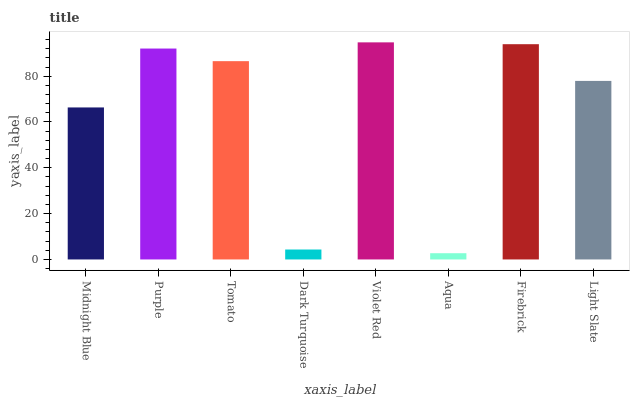Is Aqua the minimum?
Answer yes or no. Yes. Is Violet Red the maximum?
Answer yes or no. Yes. Is Purple the minimum?
Answer yes or no. No. Is Purple the maximum?
Answer yes or no. No. Is Purple greater than Midnight Blue?
Answer yes or no. Yes. Is Midnight Blue less than Purple?
Answer yes or no. Yes. Is Midnight Blue greater than Purple?
Answer yes or no. No. Is Purple less than Midnight Blue?
Answer yes or no. No. Is Tomato the high median?
Answer yes or no. Yes. Is Light Slate the low median?
Answer yes or no. Yes. Is Aqua the high median?
Answer yes or no. No. Is Midnight Blue the low median?
Answer yes or no. No. 